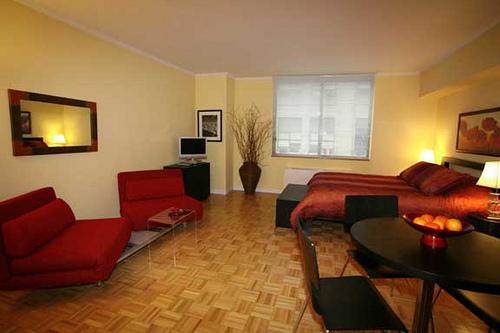Are there a lot of warm colors in this room?
Short answer required. Yes. What color are the chairs?
Give a very brief answer. Red. How many vases appear in the room?
Quick response, please. 1. Is this a hotel room?
Write a very short answer. Yes. What is this room used for?
Keep it brief. Sleeping. 